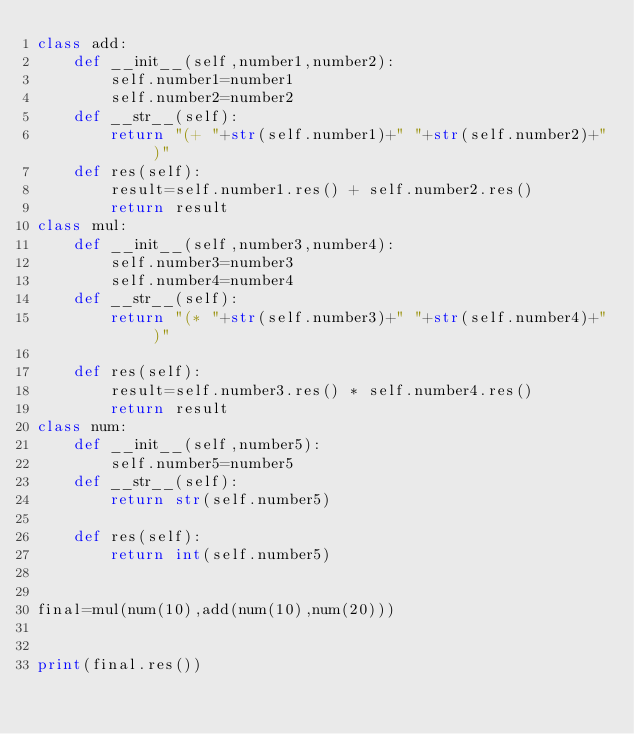<code> <loc_0><loc_0><loc_500><loc_500><_Python_>class add:
    def __init__(self,number1,number2):
        self.number1=number1
        self.number2=number2
    def __str__(self):
        return "(+ "+str(self.number1)+" "+str(self.number2)+" )"
    def res(self):
        result=self.number1.res() + self.number2.res()
        return result    
class mul:
    def __init__(self,number3,number4):
        self.number3=number3
        self.number4=number4
    def __str__(self):
        return "(* "+str(self.number3)+" "+str(self.number4)+" )"

    def res(self):
        result=self.number3.res() * self.number4.res()
        return result
class num:
    def __init__(self,number5):
        self.number5=number5
    def __str__(self):
        return str(self.number5)

    def res(self):
        return int(self.number5)


final=mul(num(10),add(num(10),num(20)))


print(final.res())


</code> 